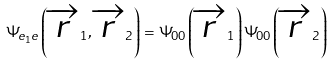Convert formula to latex. <formula><loc_0><loc_0><loc_500><loc_500>\Psi _ { e _ { 1 } e } \left ( \overrightarrow { r } _ { 1 } , \overrightarrow { r } _ { 2 } \right ) = \Psi _ { 0 0 } \left ( \overrightarrow { r } _ { 1 } \right ) \Psi _ { 0 0 } \left ( \overrightarrow { r } _ { 2 } \right )</formula> 